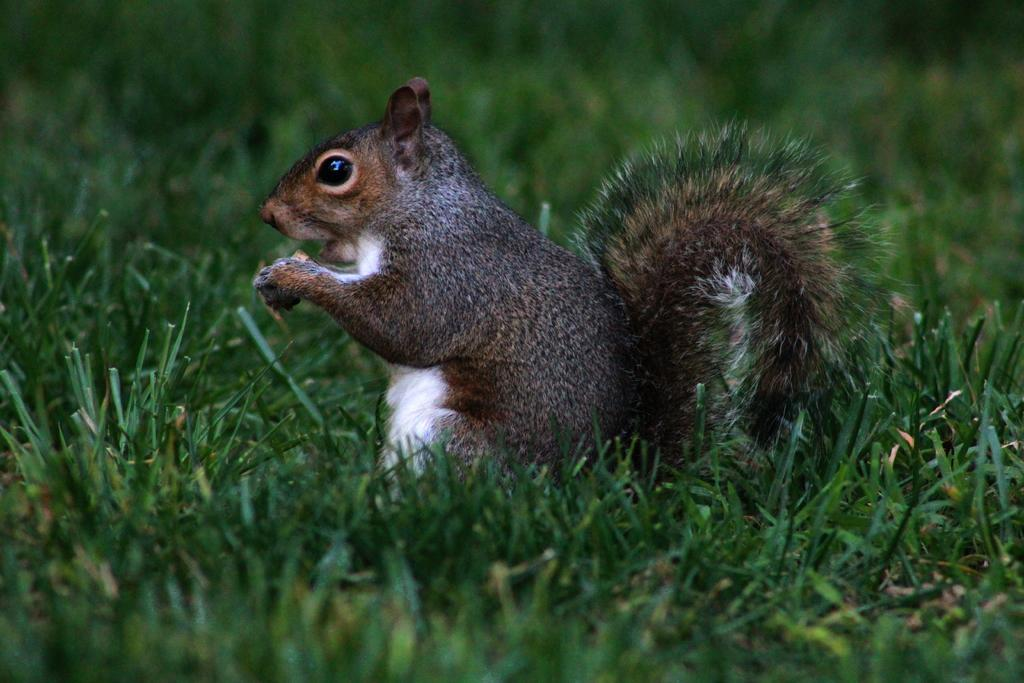Where was the picture taken? The picture was clicked outside. What is the main subject of the image? There is a squirrel in the center of the image. What is the squirrel doing in the image? The squirrel appears to be holding an object. What type of vegetation is visible in the foreground of the image? There is green grass in the foreground of the image. What type of pickle is the squirrel eating in the image? There is no pickle present in the image; the squirrel is holding an object, but it is not a pickle. How does the squirrel's temper affect the image? There is no indication of the squirrel's temper in the image, as it is a still photograph. 